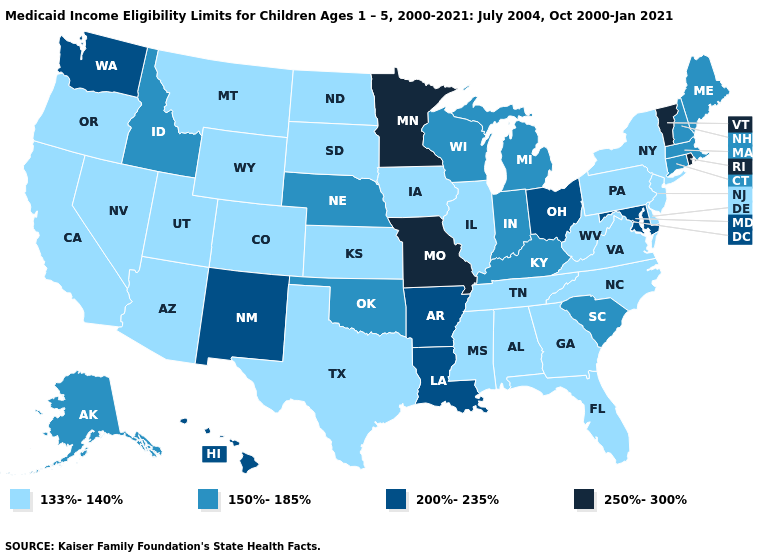What is the value of Missouri?
Give a very brief answer. 250%-300%. Name the states that have a value in the range 200%-235%?
Give a very brief answer. Arkansas, Hawaii, Louisiana, Maryland, New Mexico, Ohio, Washington. Name the states that have a value in the range 200%-235%?
Concise answer only. Arkansas, Hawaii, Louisiana, Maryland, New Mexico, Ohio, Washington. Does the first symbol in the legend represent the smallest category?
Concise answer only. Yes. Name the states that have a value in the range 150%-185%?
Quick response, please. Alaska, Connecticut, Idaho, Indiana, Kentucky, Maine, Massachusetts, Michigan, Nebraska, New Hampshire, Oklahoma, South Carolina, Wisconsin. Among the states that border Massachusetts , does Connecticut have the highest value?
Give a very brief answer. No. Does the map have missing data?
Write a very short answer. No. Does New Mexico have a higher value than Idaho?
Write a very short answer. Yes. What is the lowest value in the MidWest?
Short answer required. 133%-140%. What is the highest value in states that border Arizona?
Answer briefly. 200%-235%. Name the states that have a value in the range 250%-300%?
Concise answer only. Minnesota, Missouri, Rhode Island, Vermont. What is the value of Montana?
Concise answer only. 133%-140%. What is the highest value in the USA?
Answer briefly. 250%-300%. Among the states that border Oregon , which have the lowest value?
Give a very brief answer. California, Nevada. What is the value of Louisiana?
Quick response, please. 200%-235%. 